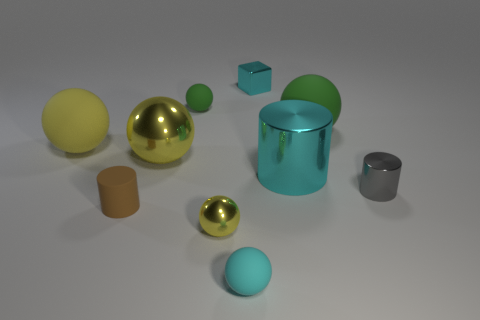Subtract all yellow balls. How many were subtracted if there are1yellow balls left? 2 Subtract all green matte spheres. How many spheres are left? 4 Subtract all blocks. How many objects are left? 9 Subtract all green spheres. How many spheres are left? 4 Subtract 1 cubes. How many cubes are left? 0 Subtract all brown balls. How many green cubes are left? 0 Subtract all rubber cylinders. Subtract all small gray metal objects. How many objects are left? 8 Add 1 big cyan objects. How many big cyan objects are left? 2 Add 9 big green matte things. How many big green matte things exist? 10 Subtract 0 green blocks. How many objects are left? 10 